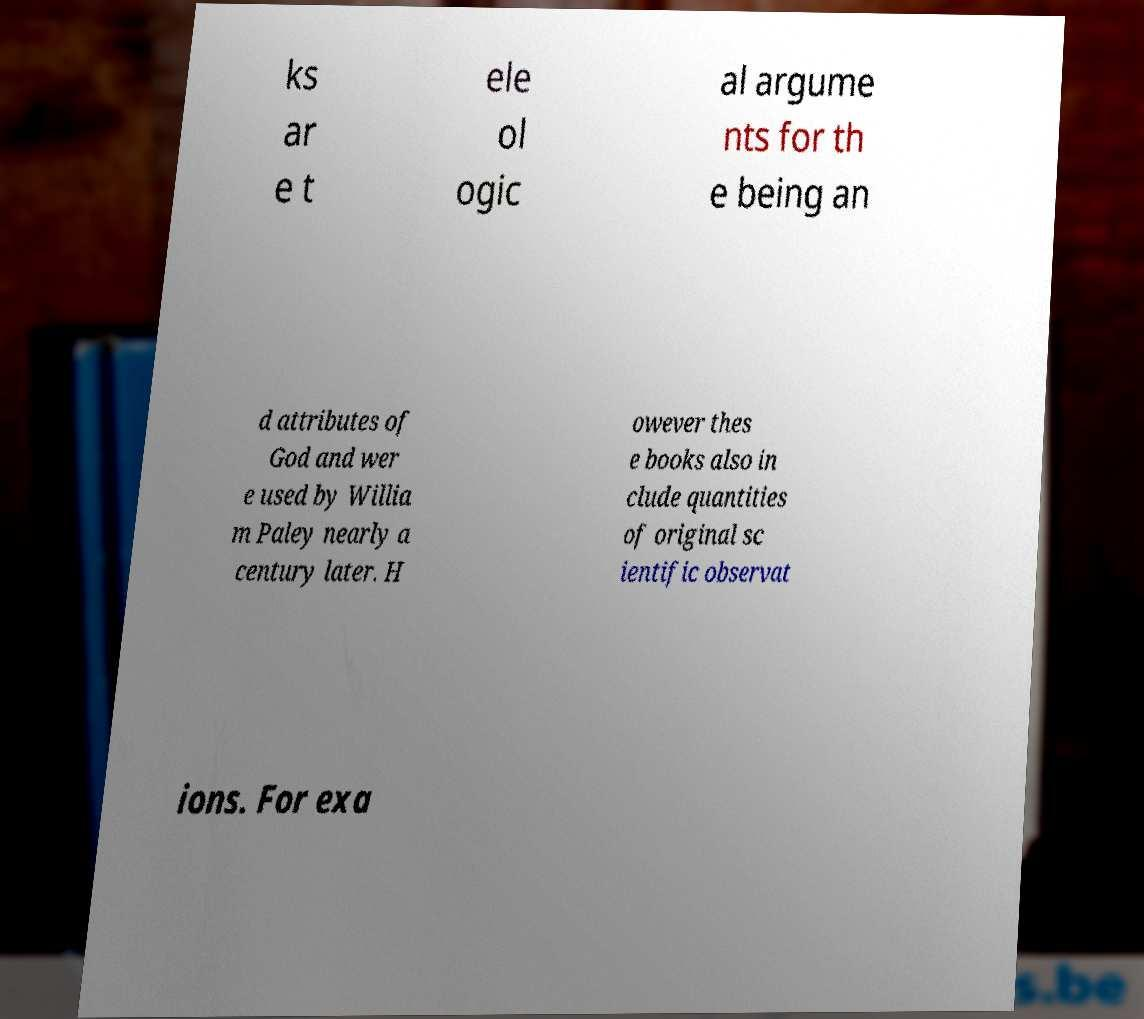Please read and relay the text visible in this image. What does it say? ks ar e t ele ol ogic al argume nts for th e being an d attributes of God and wer e used by Willia m Paley nearly a century later. H owever thes e books also in clude quantities of original sc ientific observat ions. For exa 